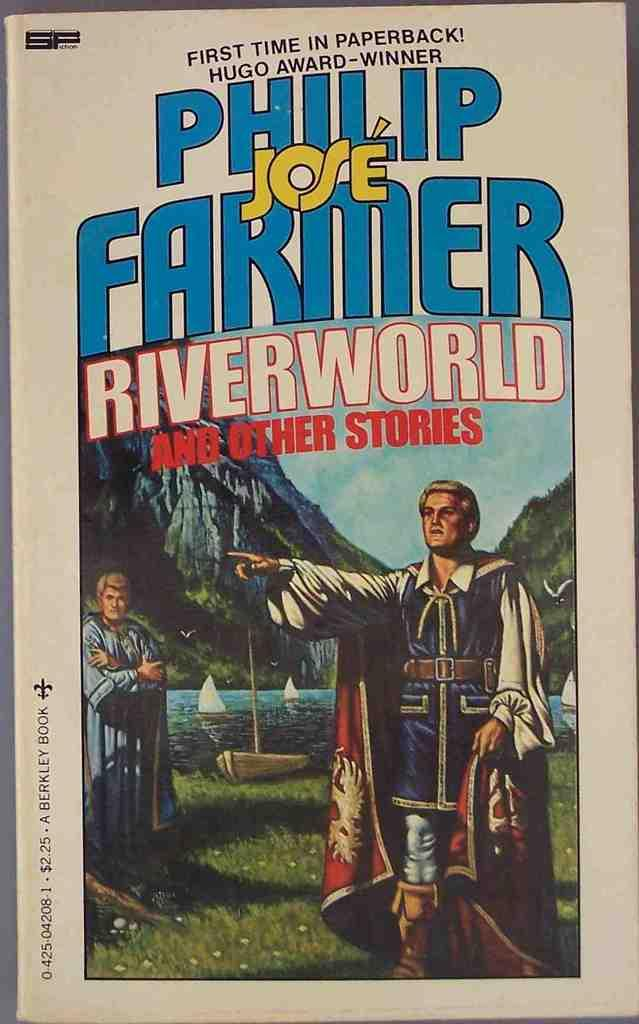<image>
Render a clear and concise summary of the photo. a book about Riverworld and some other stories 